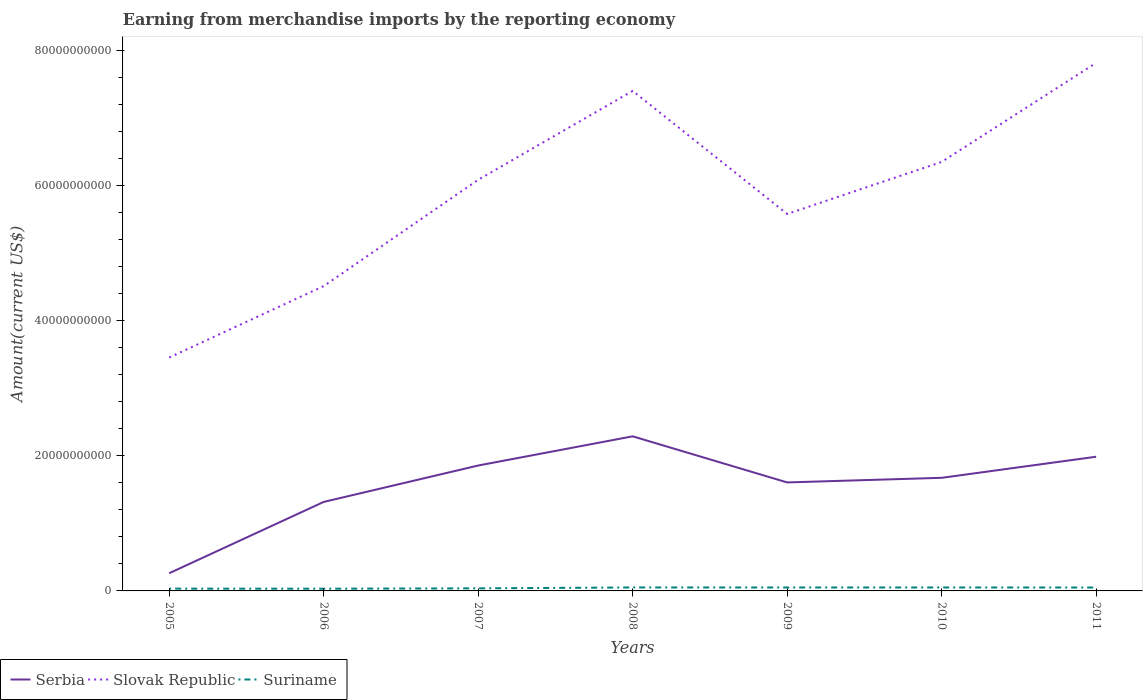How many different coloured lines are there?
Provide a short and direct response. 3. Does the line corresponding to Suriname intersect with the line corresponding to Serbia?
Provide a short and direct response. No. Is the number of lines equal to the number of legend labels?
Ensure brevity in your answer.  Yes. Across all years, what is the maximum amount earned from merchandise imports in Slovak Republic?
Provide a short and direct response. 3.45e+1. In which year was the amount earned from merchandise imports in Serbia maximum?
Your answer should be compact. 2005. What is the total amount earned from merchandise imports in Suriname in the graph?
Give a very brief answer. 1.11e+07. What is the difference between the highest and the second highest amount earned from merchandise imports in Serbia?
Your answer should be compact. 2.03e+1. Is the amount earned from merchandise imports in Suriname strictly greater than the amount earned from merchandise imports in Slovak Republic over the years?
Offer a terse response. Yes. How many lines are there?
Provide a short and direct response. 3. Are the values on the major ticks of Y-axis written in scientific E-notation?
Offer a very short reply. No. Where does the legend appear in the graph?
Your answer should be very brief. Bottom left. How are the legend labels stacked?
Provide a succinct answer. Horizontal. What is the title of the graph?
Your answer should be very brief. Earning from merchandise imports by the reporting economy. Does "Dominican Republic" appear as one of the legend labels in the graph?
Offer a very short reply. No. What is the label or title of the Y-axis?
Keep it short and to the point. Amount(current US$). What is the Amount(current US$) in Serbia in 2005?
Your response must be concise. 2.62e+09. What is the Amount(current US$) of Slovak Republic in 2005?
Provide a succinct answer. 3.45e+1. What is the Amount(current US$) of Suriname in 2005?
Your answer should be compact. 3.40e+08. What is the Amount(current US$) in Serbia in 2006?
Give a very brief answer. 1.32e+1. What is the Amount(current US$) in Slovak Republic in 2006?
Your response must be concise. 4.51e+1. What is the Amount(current US$) in Suriname in 2006?
Ensure brevity in your answer.  3.29e+08. What is the Amount(current US$) of Serbia in 2007?
Make the answer very short. 1.86e+1. What is the Amount(current US$) of Slovak Republic in 2007?
Your answer should be compact. 6.08e+1. What is the Amount(current US$) in Suriname in 2007?
Keep it short and to the point. 3.81e+08. What is the Amount(current US$) in Serbia in 2008?
Your response must be concise. 2.29e+1. What is the Amount(current US$) in Slovak Republic in 2008?
Provide a short and direct response. 7.40e+1. What is the Amount(current US$) of Suriname in 2008?
Give a very brief answer. 5.13e+08. What is the Amount(current US$) in Serbia in 2009?
Offer a terse response. 1.61e+1. What is the Amount(current US$) of Slovak Republic in 2009?
Make the answer very short. 5.58e+1. What is the Amount(current US$) of Suriname in 2009?
Offer a very short reply. 5.07e+08. What is the Amount(current US$) in Serbia in 2010?
Your response must be concise. 1.67e+1. What is the Amount(current US$) of Slovak Republic in 2010?
Your answer should be very brief. 6.35e+1. What is the Amount(current US$) in Suriname in 2010?
Your answer should be compact. 5.09e+08. What is the Amount(current US$) of Serbia in 2011?
Offer a very short reply. 1.99e+1. What is the Amount(current US$) of Slovak Republic in 2011?
Your answer should be very brief. 7.81e+1. What is the Amount(current US$) in Suriname in 2011?
Provide a succinct answer. 5.01e+08. Across all years, what is the maximum Amount(current US$) of Serbia?
Give a very brief answer. 2.29e+1. Across all years, what is the maximum Amount(current US$) of Slovak Republic?
Give a very brief answer. 7.81e+1. Across all years, what is the maximum Amount(current US$) in Suriname?
Your answer should be very brief. 5.13e+08. Across all years, what is the minimum Amount(current US$) in Serbia?
Your answer should be very brief. 2.62e+09. Across all years, what is the minimum Amount(current US$) in Slovak Republic?
Give a very brief answer. 3.45e+1. Across all years, what is the minimum Amount(current US$) in Suriname?
Your answer should be very brief. 3.29e+08. What is the total Amount(current US$) of Serbia in the graph?
Your answer should be compact. 1.10e+11. What is the total Amount(current US$) of Slovak Republic in the graph?
Your response must be concise. 4.12e+11. What is the total Amount(current US$) of Suriname in the graph?
Ensure brevity in your answer.  3.08e+09. What is the difference between the Amount(current US$) of Serbia in 2005 and that in 2006?
Your response must be concise. -1.05e+1. What is the difference between the Amount(current US$) in Slovak Republic in 2005 and that in 2006?
Offer a very short reply. -1.06e+1. What is the difference between the Amount(current US$) of Suriname in 2005 and that in 2006?
Provide a succinct answer. 1.06e+07. What is the difference between the Amount(current US$) of Serbia in 2005 and that in 2007?
Keep it short and to the point. -1.59e+1. What is the difference between the Amount(current US$) in Slovak Republic in 2005 and that in 2007?
Ensure brevity in your answer.  -2.63e+1. What is the difference between the Amount(current US$) of Suriname in 2005 and that in 2007?
Provide a succinct answer. -4.10e+07. What is the difference between the Amount(current US$) in Serbia in 2005 and that in 2008?
Ensure brevity in your answer.  -2.03e+1. What is the difference between the Amount(current US$) in Slovak Republic in 2005 and that in 2008?
Provide a succinct answer. -3.94e+1. What is the difference between the Amount(current US$) of Suriname in 2005 and that in 2008?
Give a very brief answer. -1.73e+08. What is the difference between the Amount(current US$) of Serbia in 2005 and that in 2009?
Your answer should be very brief. -1.34e+1. What is the difference between the Amount(current US$) in Slovak Republic in 2005 and that in 2009?
Provide a succinct answer. -2.12e+1. What is the difference between the Amount(current US$) of Suriname in 2005 and that in 2009?
Ensure brevity in your answer.  -1.68e+08. What is the difference between the Amount(current US$) of Serbia in 2005 and that in 2010?
Your answer should be compact. -1.41e+1. What is the difference between the Amount(current US$) in Slovak Republic in 2005 and that in 2010?
Make the answer very short. -2.89e+1. What is the difference between the Amount(current US$) in Suriname in 2005 and that in 2010?
Offer a terse response. -1.69e+08. What is the difference between the Amount(current US$) in Serbia in 2005 and that in 2011?
Provide a succinct answer. -1.72e+1. What is the difference between the Amount(current US$) in Slovak Republic in 2005 and that in 2011?
Make the answer very short. -4.36e+1. What is the difference between the Amount(current US$) of Suriname in 2005 and that in 2011?
Offer a terse response. -1.62e+08. What is the difference between the Amount(current US$) in Serbia in 2006 and that in 2007?
Give a very brief answer. -5.39e+09. What is the difference between the Amount(current US$) in Slovak Republic in 2006 and that in 2007?
Give a very brief answer. -1.57e+1. What is the difference between the Amount(current US$) of Suriname in 2006 and that in 2007?
Ensure brevity in your answer.  -5.16e+07. What is the difference between the Amount(current US$) in Serbia in 2006 and that in 2008?
Provide a succinct answer. -9.71e+09. What is the difference between the Amount(current US$) of Slovak Republic in 2006 and that in 2008?
Ensure brevity in your answer.  -2.89e+1. What is the difference between the Amount(current US$) in Suriname in 2006 and that in 2008?
Offer a terse response. -1.84e+08. What is the difference between the Amount(current US$) in Serbia in 2006 and that in 2009?
Keep it short and to the point. -2.88e+09. What is the difference between the Amount(current US$) of Slovak Republic in 2006 and that in 2009?
Provide a short and direct response. -1.07e+1. What is the difference between the Amount(current US$) in Suriname in 2006 and that in 2009?
Offer a terse response. -1.78e+08. What is the difference between the Amount(current US$) in Serbia in 2006 and that in 2010?
Provide a short and direct response. -3.57e+09. What is the difference between the Amount(current US$) of Slovak Republic in 2006 and that in 2010?
Provide a short and direct response. -1.84e+1. What is the difference between the Amount(current US$) of Suriname in 2006 and that in 2010?
Your answer should be very brief. -1.80e+08. What is the difference between the Amount(current US$) of Serbia in 2006 and that in 2011?
Keep it short and to the point. -6.69e+09. What is the difference between the Amount(current US$) in Slovak Republic in 2006 and that in 2011?
Provide a succinct answer. -3.30e+1. What is the difference between the Amount(current US$) in Suriname in 2006 and that in 2011?
Ensure brevity in your answer.  -1.72e+08. What is the difference between the Amount(current US$) of Serbia in 2007 and that in 2008?
Ensure brevity in your answer.  -4.32e+09. What is the difference between the Amount(current US$) in Slovak Republic in 2007 and that in 2008?
Provide a short and direct response. -1.31e+1. What is the difference between the Amount(current US$) in Suriname in 2007 and that in 2008?
Ensure brevity in your answer.  -1.32e+08. What is the difference between the Amount(current US$) in Serbia in 2007 and that in 2009?
Keep it short and to the point. 2.50e+09. What is the difference between the Amount(current US$) of Slovak Republic in 2007 and that in 2009?
Give a very brief answer. 5.06e+09. What is the difference between the Amount(current US$) in Suriname in 2007 and that in 2009?
Your response must be concise. -1.27e+08. What is the difference between the Amount(current US$) in Serbia in 2007 and that in 2010?
Keep it short and to the point. 1.82e+09. What is the difference between the Amount(current US$) of Slovak Republic in 2007 and that in 2010?
Make the answer very short. -2.64e+09. What is the difference between the Amount(current US$) in Suriname in 2007 and that in 2010?
Offer a very short reply. -1.29e+08. What is the difference between the Amount(current US$) of Serbia in 2007 and that in 2011?
Give a very brief answer. -1.30e+09. What is the difference between the Amount(current US$) of Slovak Republic in 2007 and that in 2011?
Provide a succinct answer. -1.73e+1. What is the difference between the Amount(current US$) of Suriname in 2007 and that in 2011?
Give a very brief answer. -1.21e+08. What is the difference between the Amount(current US$) of Serbia in 2008 and that in 2009?
Ensure brevity in your answer.  6.82e+09. What is the difference between the Amount(current US$) in Slovak Republic in 2008 and that in 2009?
Provide a short and direct response. 1.82e+1. What is the difference between the Amount(current US$) of Suriname in 2008 and that in 2009?
Keep it short and to the point. 5.24e+06. What is the difference between the Amount(current US$) in Serbia in 2008 and that in 2010?
Offer a terse response. 6.14e+09. What is the difference between the Amount(current US$) in Slovak Republic in 2008 and that in 2010?
Your answer should be compact. 1.05e+1. What is the difference between the Amount(current US$) in Suriname in 2008 and that in 2010?
Provide a succinct answer. 3.37e+06. What is the difference between the Amount(current US$) in Serbia in 2008 and that in 2011?
Your response must be concise. 3.02e+09. What is the difference between the Amount(current US$) of Slovak Republic in 2008 and that in 2011?
Give a very brief answer. -4.15e+09. What is the difference between the Amount(current US$) of Suriname in 2008 and that in 2011?
Offer a terse response. 1.11e+07. What is the difference between the Amount(current US$) in Serbia in 2009 and that in 2010?
Your response must be concise. -6.82e+08. What is the difference between the Amount(current US$) of Slovak Republic in 2009 and that in 2010?
Offer a terse response. -7.70e+09. What is the difference between the Amount(current US$) in Suriname in 2009 and that in 2010?
Ensure brevity in your answer.  -1.87e+06. What is the difference between the Amount(current US$) in Serbia in 2009 and that in 2011?
Give a very brief answer. -3.80e+09. What is the difference between the Amount(current US$) in Slovak Republic in 2009 and that in 2011?
Your answer should be very brief. -2.24e+1. What is the difference between the Amount(current US$) in Suriname in 2009 and that in 2011?
Give a very brief answer. 5.88e+06. What is the difference between the Amount(current US$) of Serbia in 2010 and that in 2011?
Make the answer very short. -3.12e+09. What is the difference between the Amount(current US$) in Slovak Republic in 2010 and that in 2011?
Your answer should be compact. -1.47e+1. What is the difference between the Amount(current US$) in Suriname in 2010 and that in 2011?
Offer a very short reply. 7.75e+06. What is the difference between the Amount(current US$) of Serbia in 2005 and the Amount(current US$) of Slovak Republic in 2006?
Give a very brief answer. -4.25e+1. What is the difference between the Amount(current US$) of Serbia in 2005 and the Amount(current US$) of Suriname in 2006?
Ensure brevity in your answer.  2.29e+09. What is the difference between the Amount(current US$) in Slovak Republic in 2005 and the Amount(current US$) in Suriname in 2006?
Keep it short and to the point. 3.42e+1. What is the difference between the Amount(current US$) in Serbia in 2005 and the Amount(current US$) in Slovak Republic in 2007?
Make the answer very short. -5.82e+1. What is the difference between the Amount(current US$) in Serbia in 2005 and the Amount(current US$) in Suriname in 2007?
Keep it short and to the point. 2.24e+09. What is the difference between the Amount(current US$) of Slovak Republic in 2005 and the Amount(current US$) of Suriname in 2007?
Keep it short and to the point. 3.42e+1. What is the difference between the Amount(current US$) in Serbia in 2005 and the Amount(current US$) in Slovak Republic in 2008?
Keep it short and to the point. -7.14e+1. What is the difference between the Amount(current US$) of Serbia in 2005 and the Amount(current US$) of Suriname in 2008?
Ensure brevity in your answer.  2.11e+09. What is the difference between the Amount(current US$) in Slovak Republic in 2005 and the Amount(current US$) in Suriname in 2008?
Your answer should be very brief. 3.40e+1. What is the difference between the Amount(current US$) in Serbia in 2005 and the Amount(current US$) in Slovak Republic in 2009?
Offer a terse response. -5.32e+1. What is the difference between the Amount(current US$) in Serbia in 2005 and the Amount(current US$) in Suriname in 2009?
Offer a terse response. 2.11e+09. What is the difference between the Amount(current US$) in Slovak Republic in 2005 and the Amount(current US$) in Suriname in 2009?
Your answer should be compact. 3.40e+1. What is the difference between the Amount(current US$) in Serbia in 2005 and the Amount(current US$) in Slovak Republic in 2010?
Your answer should be very brief. -6.09e+1. What is the difference between the Amount(current US$) of Serbia in 2005 and the Amount(current US$) of Suriname in 2010?
Provide a short and direct response. 2.11e+09. What is the difference between the Amount(current US$) in Slovak Republic in 2005 and the Amount(current US$) in Suriname in 2010?
Provide a short and direct response. 3.40e+1. What is the difference between the Amount(current US$) of Serbia in 2005 and the Amount(current US$) of Slovak Republic in 2011?
Offer a very short reply. -7.55e+1. What is the difference between the Amount(current US$) in Serbia in 2005 and the Amount(current US$) in Suriname in 2011?
Your answer should be very brief. 2.12e+09. What is the difference between the Amount(current US$) in Slovak Republic in 2005 and the Amount(current US$) in Suriname in 2011?
Your answer should be very brief. 3.40e+1. What is the difference between the Amount(current US$) of Serbia in 2006 and the Amount(current US$) of Slovak Republic in 2007?
Make the answer very short. -4.77e+1. What is the difference between the Amount(current US$) in Serbia in 2006 and the Amount(current US$) in Suriname in 2007?
Offer a very short reply. 1.28e+1. What is the difference between the Amount(current US$) of Slovak Republic in 2006 and the Amount(current US$) of Suriname in 2007?
Ensure brevity in your answer.  4.47e+1. What is the difference between the Amount(current US$) of Serbia in 2006 and the Amount(current US$) of Slovak Republic in 2008?
Ensure brevity in your answer.  -6.08e+1. What is the difference between the Amount(current US$) of Serbia in 2006 and the Amount(current US$) of Suriname in 2008?
Provide a short and direct response. 1.27e+1. What is the difference between the Amount(current US$) in Slovak Republic in 2006 and the Amount(current US$) in Suriname in 2008?
Your answer should be very brief. 4.46e+1. What is the difference between the Amount(current US$) in Serbia in 2006 and the Amount(current US$) in Slovak Republic in 2009?
Your response must be concise. -4.26e+1. What is the difference between the Amount(current US$) in Serbia in 2006 and the Amount(current US$) in Suriname in 2009?
Offer a very short reply. 1.27e+1. What is the difference between the Amount(current US$) of Slovak Republic in 2006 and the Amount(current US$) of Suriname in 2009?
Keep it short and to the point. 4.46e+1. What is the difference between the Amount(current US$) of Serbia in 2006 and the Amount(current US$) of Slovak Republic in 2010?
Offer a terse response. -5.03e+1. What is the difference between the Amount(current US$) in Serbia in 2006 and the Amount(current US$) in Suriname in 2010?
Provide a short and direct response. 1.27e+1. What is the difference between the Amount(current US$) in Slovak Republic in 2006 and the Amount(current US$) in Suriname in 2010?
Give a very brief answer. 4.46e+1. What is the difference between the Amount(current US$) of Serbia in 2006 and the Amount(current US$) of Slovak Republic in 2011?
Make the answer very short. -6.50e+1. What is the difference between the Amount(current US$) of Serbia in 2006 and the Amount(current US$) of Suriname in 2011?
Keep it short and to the point. 1.27e+1. What is the difference between the Amount(current US$) in Slovak Republic in 2006 and the Amount(current US$) in Suriname in 2011?
Offer a terse response. 4.46e+1. What is the difference between the Amount(current US$) of Serbia in 2007 and the Amount(current US$) of Slovak Republic in 2008?
Ensure brevity in your answer.  -5.54e+1. What is the difference between the Amount(current US$) of Serbia in 2007 and the Amount(current US$) of Suriname in 2008?
Your answer should be very brief. 1.80e+1. What is the difference between the Amount(current US$) in Slovak Republic in 2007 and the Amount(current US$) in Suriname in 2008?
Your answer should be very brief. 6.03e+1. What is the difference between the Amount(current US$) of Serbia in 2007 and the Amount(current US$) of Slovak Republic in 2009?
Provide a succinct answer. -3.72e+1. What is the difference between the Amount(current US$) of Serbia in 2007 and the Amount(current US$) of Suriname in 2009?
Make the answer very short. 1.80e+1. What is the difference between the Amount(current US$) in Slovak Republic in 2007 and the Amount(current US$) in Suriname in 2009?
Offer a terse response. 6.03e+1. What is the difference between the Amount(current US$) in Serbia in 2007 and the Amount(current US$) in Slovak Republic in 2010?
Provide a succinct answer. -4.49e+1. What is the difference between the Amount(current US$) in Serbia in 2007 and the Amount(current US$) in Suriname in 2010?
Offer a very short reply. 1.80e+1. What is the difference between the Amount(current US$) in Slovak Republic in 2007 and the Amount(current US$) in Suriname in 2010?
Keep it short and to the point. 6.03e+1. What is the difference between the Amount(current US$) of Serbia in 2007 and the Amount(current US$) of Slovak Republic in 2011?
Make the answer very short. -5.96e+1. What is the difference between the Amount(current US$) in Serbia in 2007 and the Amount(current US$) in Suriname in 2011?
Your answer should be compact. 1.81e+1. What is the difference between the Amount(current US$) of Slovak Republic in 2007 and the Amount(current US$) of Suriname in 2011?
Your response must be concise. 6.03e+1. What is the difference between the Amount(current US$) of Serbia in 2008 and the Amount(current US$) of Slovak Republic in 2009?
Make the answer very short. -3.29e+1. What is the difference between the Amount(current US$) in Serbia in 2008 and the Amount(current US$) in Suriname in 2009?
Offer a very short reply. 2.24e+1. What is the difference between the Amount(current US$) in Slovak Republic in 2008 and the Amount(current US$) in Suriname in 2009?
Offer a very short reply. 7.35e+1. What is the difference between the Amount(current US$) of Serbia in 2008 and the Amount(current US$) of Slovak Republic in 2010?
Offer a terse response. -4.06e+1. What is the difference between the Amount(current US$) of Serbia in 2008 and the Amount(current US$) of Suriname in 2010?
Offer a very short reply. 2.24e+1. What is the difference between the Amount(current US$) of Slovak Republic in 2008 and the Amount(current US$) of Suriname in 2010?
Your response must be concise. 7.35e+1. What is the difference between the Amount(current US$) in Serbia in 2008 and the Amount(current US$) in Slovak Republic in 2011?
Provide a succinct answer. -5.53e+1. What is the difference between the Amount(current US$) in Serbia in 2008 and the Amount(current US$) in Suriname in 2011?
Ensure brevity in your answer.  2.24e+1. What is the difference between the Amount(current US$) in Slovak Republic in 2008 and the Amount(current US$) in Suriname in 2011?
Keep it short and to the point. 7.35e+1. What is the difference between the Amount(current US$) in Serbia in 2009 and the Amount(current US$) in Slovak Republic in 2010?
Provide a short and direct response. -4.74e+1. What is the difference between the Amount(current US$) in Serbia in 2009 and the Amount(current US$) in Suriname in 2010?
Offer a very short reply. 1.55e+1. What is the difference between the Amount(current US$) of Slovak Republic in 2009 and the Amount(current US$) of Suriname in 2010?
Offer a very short reply. 5.53e+1. What is the difference between the Amount(current US$) of Serbia in 2009 and the Amount(current US$) of Slovak Republic in 2011?
Provide a succinct answer. -6.21e+1. What is the difference between the Amount(current US$) in Serbia in 2009 and the Amount(current US$) in Suriname in 2011?
Your response must be concise. 1.56e+1. What is the difference between the Amount(current US$) of Slovak Republic in 2009 and the Amount(current US$) of Suriname in 2011?
Give a very brief answer. 5.53e+1. What is the difference between the Amount(current US$) in Serbia in 2010 and the Amount(current US$) in Slovak Republic in 2011?
Your response must be concise. -6.14e+1. What is the difference between the Amount(current US$) of Serbia in 2010 and the Amount(current US$) of Suriname in 2011?
Your answer should be compact. 1.62e+1. What is the difference between the Amount(current US$) in Slovak Republic in 2010 and the Amount(current US$) in Suriname in 2011?
Offer a terse response. 6.30e+1. What is the average Amount(current US$) in Serbia per year?
Offer a very short reply. 1.57e+1. What is the average Amount(current US$) in Slovak Republic per year?
Make the answer very short. 5.88e+1. What is the average Amount(current US$) in Suriname per year?
Make the answer very short. 4.40e+08. In the year 2005, what is the difference between the Amount(current US$) of Serbia and Amount(current US$) of Slovak Republic?
Your answer should be very brief. -3.19e+1. In the year 2005, what is the difference between the Amount(current US$) in Serbia and Amount(current US$) in Suriname?
Make the answer very short. 2.28e+09. In the year 2005, what is the difference between the Amount(current US$) of Slovak Republic and Amount(current US$) of Suriname?
Keep it short and to the point. 3.42e+1. In the year 2006, what is the difference between the Amount(current US$) in Serbia and Amount(current US$) in Slovak Republic?
Offer a very short reply. -3.19e+1. In the year 2006, what is the difference between the Amount(current US$) of Serbia and Amount(current US$) of Suriname?
Ensure brevity in your answer.  1.28e+1. In the year 2006, what is the difference between the Amount(current US$) in Slovak Republic and Amount(current US$) in Suriname?
Offer a very short reply. 4.48e+1. In the year 2007, what is the difference between the Amount(current US$) in Serbia and Amount(current US$) in Slovak Republic?
Make the answer very short. -4.23e+1. In the year 2007, what is the difference between the Amount(current US$) of Serbia and Amount(current US$) of Suriname?
Keep it short and to the point. 1.82e+1. In the year 2007, what is the difference between the Amount(current US$) of Slovak Republic and Amount(current US$) of Suriname?
Provide a succinct answer. 6.05e+1. In the year 2008, what is the difference between the Amount(current US$) of Serbia and Amount(current US$) of Slovak Republic?
Make the answer very short. -5.11e+1. In the year 2008, what is the difference between the Amount(current US$) in Serbia and Amount(current US$) in Suriname?
Make the answer very short. 2.24e+1. In the year 2008, what is the difference between the Amount(current US$) of Slovak Republic and Amount(current US$) of Suriname?
Keep it short and to the point. 7.35e+1. In the year 2009, what is the difference between the Amount(current US$) of Serbia and Amount(current US$) of Slovak Republic?
Provide a succinct answer. -3.97e+1. In the year 2009, what is the difference between the Amount(current US$) in Serbia and Amount(current US$) in Suriname?
Offer a terse response. 1.55e+1. In the year 2009, what is the difference between the Amount(current US$) in Slovak Republic and Amount(current US$) in Suriname?
Provide a short and direct response. 5.53e+1. In the year 2010, what is the difference between the Amount(current US$) in Serbia and Amount(current US$) in Slovak Republic?
Make the answer very short. -4.67e+1. In the year 2010, what is the difference between the Amount(current US$) of Serbia and Amount(current US$) of Suriname?
Make the answer very short. 1.62e+1. In the year 2010, what is the difference between the Amount(current US$) in Slovak Republic and Amount(current US$) in Suriname?
Ensure brevity in your answer.  6.30e+1. In the year 2011, what is the difference between the Amount(current US$) of Serbia and Amount(current US$) of Slovak Republic?
Make the answer very short. -5.83e+1. In the year 2011, what is the difference between the Amount(current US$) in Serbia and Amount(current US$) in Suriname?
Your answer should be very brief. 1.94e+1. In the year 2011, what is the difference between the Amount(current US$) of Slovak Republic and Amount(current US$) of Suriname?
Keep it short and to the point. 7.76e+1. What is the ratio of the Amount(current US$) in Serbia in 2005 to that in 2006?
Provide a succinct answer. 0.2. What is the ratio of the Amount(current US$) in Slovak Republic in 2005 to that in 2006?
Make the answer very short. 0.77. What is the ratio of the Amount(current US$) of Suriname in 2005 to that in 2006?
Ensure brevity in your answer.  1.03. What is the ratio of the Amount(current US$) in Serbia in 2005 to that in 2007?
Offer a terse response. 0.14. What is the ratio of the Amount(current US$) in Slovak Republic in 2005 to that in 2007?
Make the answer very short. 0.57. What is the ratio of the Amount(current US$) of Suriname in 2005 to that in 2007?
Keep it short and to the point. 0.89. What is the ratio of the Amount(current US$) in Serbia in 2005 to that in 2008?
Your response must be concise. 0.11. What is the ratio of the Amount(current US$) of Slovak Republic in 2005 to that in 2008?
Your response must be concise. 0.47. What is the ratio of the Amount(current US$) of Suriname in 2005 to that in 2008?
Offer a very short reply. 0.66. What is the ratio of the Amount(current US$) of Serbia in 2005 to that in 2009?
Keep it short and to the point. 0.16. What is the ratio of the Amount(current US$) of Slovak Republic in 2005 to that in 2009?
Provide a succinct answer. 0.62. What is the ratio of the Amount(current US$) in Suriname in 2005 to that in 2009?
Give a very brief answer. 0.67. What is the ratio of the Amount(current US$) of Serbia in 2005 to that in 2010?
Offer a very short reply. 0.16. What is the ratio of the Amount(current US$) in Slovak Republic in 2005 to that in 2010?
Your response must be concise. 0.54. What is the ratio of the Amount(current US$) in Suriname in 2005 to that in 2010?
Make the answer very short. 0.67. What is the ratio of the Amount(current US$) in Serbia in 2005 to that in 2011?
Offer a terse response. 0.13. What is the ratio of the Amount(current US$) of Slovak Republic in 2005 to that in 2011?
Your response must be concise. 0.44. What is the ratio of the Amount(current US$) of Suriname in 2005 to that in 2011?
Your answer should be compact. 0.68. What is the ratio of the Amount(current US$) in Serbia in 2006 to that in 2007?
Give a very brief answer. 0.71. What is the ratio of the Amount(current US$) of Slovak Republic in 2006 to that in 2007?
Your response must be concise. 0.74. What is the ratio of the Amount(current US$) in Suriname in 2006 to that in 2007?
Offer a terse response. 0.86. What is the ratio of the Amount(current US$) of Serbia in 2006 to that in 2008?
Your answer should be very brief. 0.58. What is the ratio of the Amount(current US$) of Slovak Republic in 2006 to that in 2008?
Offer a very short reply. 0.61. What is the ratio of the Amount(current US$) of Suriname in 2006 to that in 2008?
Provide a short and direct response. 0.64. What is the ratio of the Amount(current US$) of Serbia in 2006 to that in 2009?
Provide a short and direct response. 0.82. What is the ratio of the Amount(current US$) of Slovak Republic in 2006 to that in 2009?
Make the answer very short. 0.81. What is the ratio of the Amount(current US$) of Suriname in 2006 to that in 2009?
Give a very brief answer. 0.65. What is the ratio of the Amount(current US$) of Serbia in 2006 to that in 2010?
Keep it short and to the point. 0.79. What is the ratio of the Amount(current US$) of Slovak Republic in 2006 to that in 2010?
Your response must be concise. 0.71. What is the ratio of the Amount(current US$) in Suriname in 2006 to that in 2010?
Your answer should be compact. 0.65. What is the ratio of the Amount(current US$) in Serbia in 2006 to that in 2011?
Your answer should be very brief. 0.66. What is the ratio of the Amount(current US$) of Slovak Republic in 2006 to that in 2011?
Offer a very short reply. 0.58. What is the ratio of the Amount(current US$) of Suriname in 2006 to that in 2011?
Make the answer very short. 0.66. What is the ratio of the Amount(current US$) of Serbia in 2007 to that in 2008?
Make the answer very short. 0.81. What is the ratio of the Amount(current US$) of Slovak Republic in 2007 to that in 2008?
Keep it short and to the point. 0.82. What is the ratio of the Amount(current US$) of Suriname in 2007 to that in 2008?
Provide a succinct answer. 0.74. What is the ratio of the Amount(current US$) of Serbia in 2007 to that in 2009?
Make the answer very short. 1.16. What is the ratio of the Amount(current US$) in Slovak Republic in 2007 to that in 2009?
Offer a terse response. 1.09. What is the ratio of the Amount(current US$) of Suriname in 2007 to that in 2009?
Provide a succinct answer. 0.75. What is the ratio of the Amount(current US$) of Serbia in 2007 to that in 2010?
Your answer should be compact. 1.11. What is the ratio of the Amount(current US$) in Slovak Republic in 2007 to that in 2010?
Ensure brevity in your answer.  0.96. What is the ratio of the Amount(current US$) of Suriname in 2007 to that in 2010?
Ensure brevity in your answer.  0.75. What is the ratio of the Amount(current US$) of Serbia in 2007 to that in 2011?
Offer a terse response. 0.93. What is the ratio of the Amount(current US$) of Slovak Republic in 2007 to that in 2011?
Keep it short and to the point. 0.78. What is the ratio of the Amount(current US$) in Suriname in 2007 to that in 2011?
Your answer should be compact. 0.76. What is the ratio of the Amount(current US$) in Serbia in 2008 to that in 2009?
Give a very brief answer. 1.43. What is the ratio of the Amount(current US$) of Slovak Republic in 2008 to that in 2009?
Offer a terse response. 1.33. What is the ratio of the Amount(current US$) of Suriname in 2008 to that in 2009?
Ensure brevity in your answer.  1.01. What is the ratio of the Amount(current US$) in Serbia in 2008 to that in 2010?
Offer a very short reply. 1.37. What is the ratio of the Amount(current US$) of Slovak Republic in 2008 to that in 2010?
Keep it short and to the point. 1.17. What is the ratio of the Amount(current US$) of Suriname in 2008 to that in 2010?
Your response must be concise. 1.01. What is the ratio of the Amount(current US$) in Serbia in 2008 to that in 2011?
Make the answer very short. 1.15. What is the ratio of the Amount(current US$) of Slovak Republic in 2008 to that in 2011?
Provide a succinct answer. 0.95. What is the ratio of the Amount(current US$) in Suriname in 2008 to that in 2011?
Provide a succinct answer. 1.02. What is the ratio of the Amount(current US$) of Serbia in 2009 to that in 2010?
Ensure brevity in your answer.  0.96. What is the ratio of the Amount(current US$) of Slovak Republic in 2009 to that in 2010?
Offer a terse response. 0.88. What is the ratio of the Amount(current US$) in Suriname in 2009 to that in 2010?
Your answer should be compact. 1. What is the ratio of the Amount(current US$) of Serbia in 2009 to that in 2011?
Offer a terse response. 0.81. What is the ratio of the Amount(current US$) of Slovak Republic in 2009 to that in 2011?
Provide a short and direct response. 0.71. What is the ratio of the Amount(current US$) of Suriname in 2009 to that in 2011?
Offer a terse response. 1.01. What is the ratio of the Amount(current US$) of Serbia in 2010 to that in 2011?
Offer a very short reply. 0.84. What is the ratio of the Amount(current US$) in Slovak Republic in 2010 to that in 2011?
Provide a short and direct response. 0.81. What is the ratio of the Amount(current US$) of Suriname in 2010 to that in 2011?
Ensure brevity in your answer.  1.02. What is the difference between the highest and the second highest Amount(current US$) of Serbia?
Make the answer very short. 3.02e+09. What is the difference between the highest and the second highest Amount(current US$) of Slovak Republic?
Your response must be concise. 4.15e+09. What is the difference between the highest and the second highest Amount(current US$) of Suriname?
Offer a very short reply. 3.37e+06. What is the difference between the highest and the lowest Amount(current US$) of Serbia?
Offer a terse response. 2.03e+1. What is the difference between the highest and the lowest Amount(current US$) of Slovak Republic?
Ensure brevity in your answer.  4.36e+1. What is the difference between the highest and the lowest Amount(current US$) of Suriname?
Make the answer very short. 1.84e+08. 